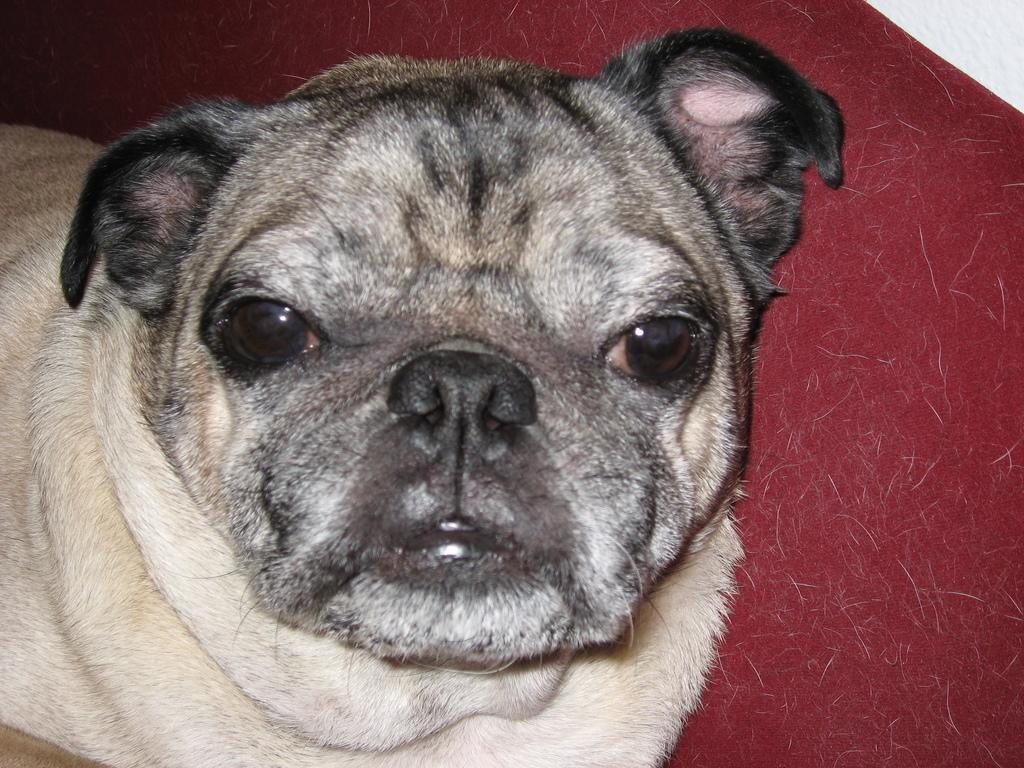What type of animal is in the image? There is a dog in the image. What color is the surface the dog is on? The dog is on a red surface. What can be seen on the red surface besides the dog? There is hair on the red surface. Can you tell me how many yaks are visible in the image? There are no yaks present in the image; it features a dog on a red surface with hair. What type of wind can be seen in the image? There is no wind visible in the image, as it is a still photograph. 